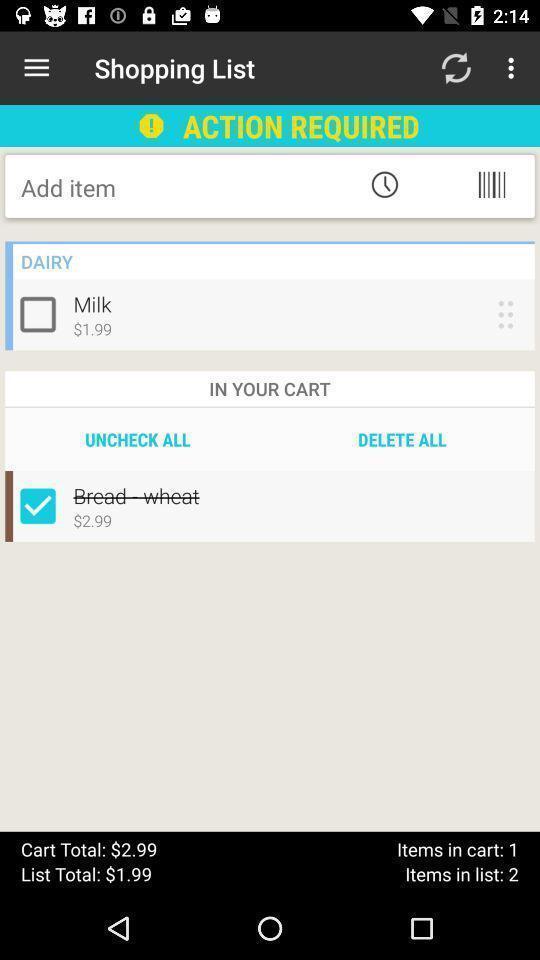Please provide a description for this image. Page showing the history of items in a shopping app. 